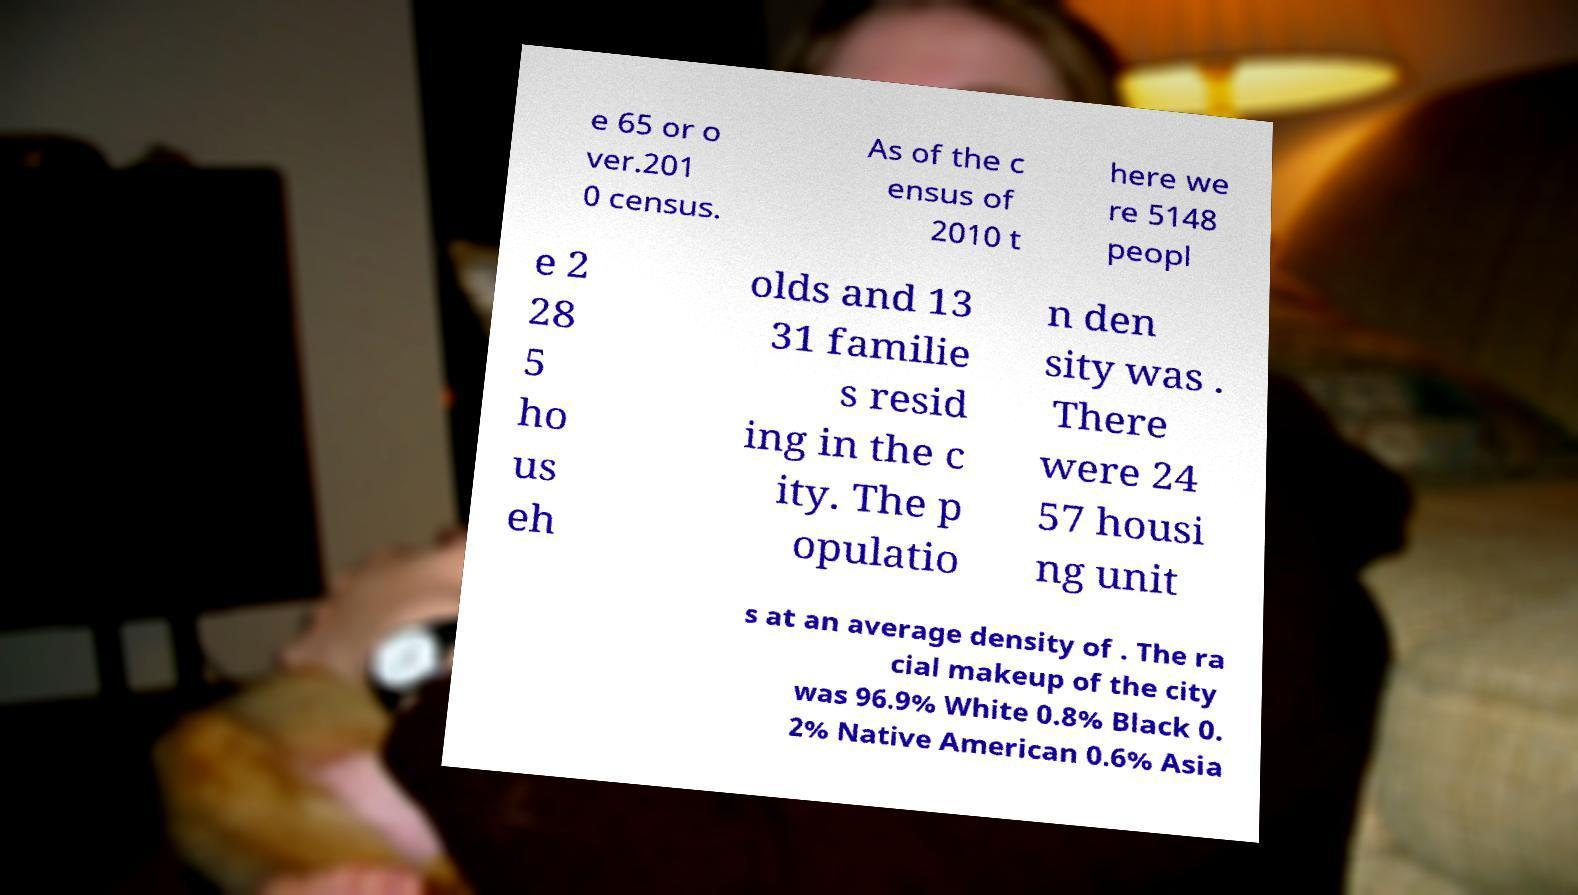Please identify and transcribe the text found in this image. e 65 or o ver.201 0 census. As of the c ensus of 2010 t here we re 5148 peopl e 2 28 5 ho us eh olds and 13 31 familie s resid ing in the c ity. The p opulatio n den sity was . There were 24 57 housi ng unit s at an average density of . The ra cial makeup of the city was 96.9% White 0.8% Black 0. 2% Native American 0.6% Asia 